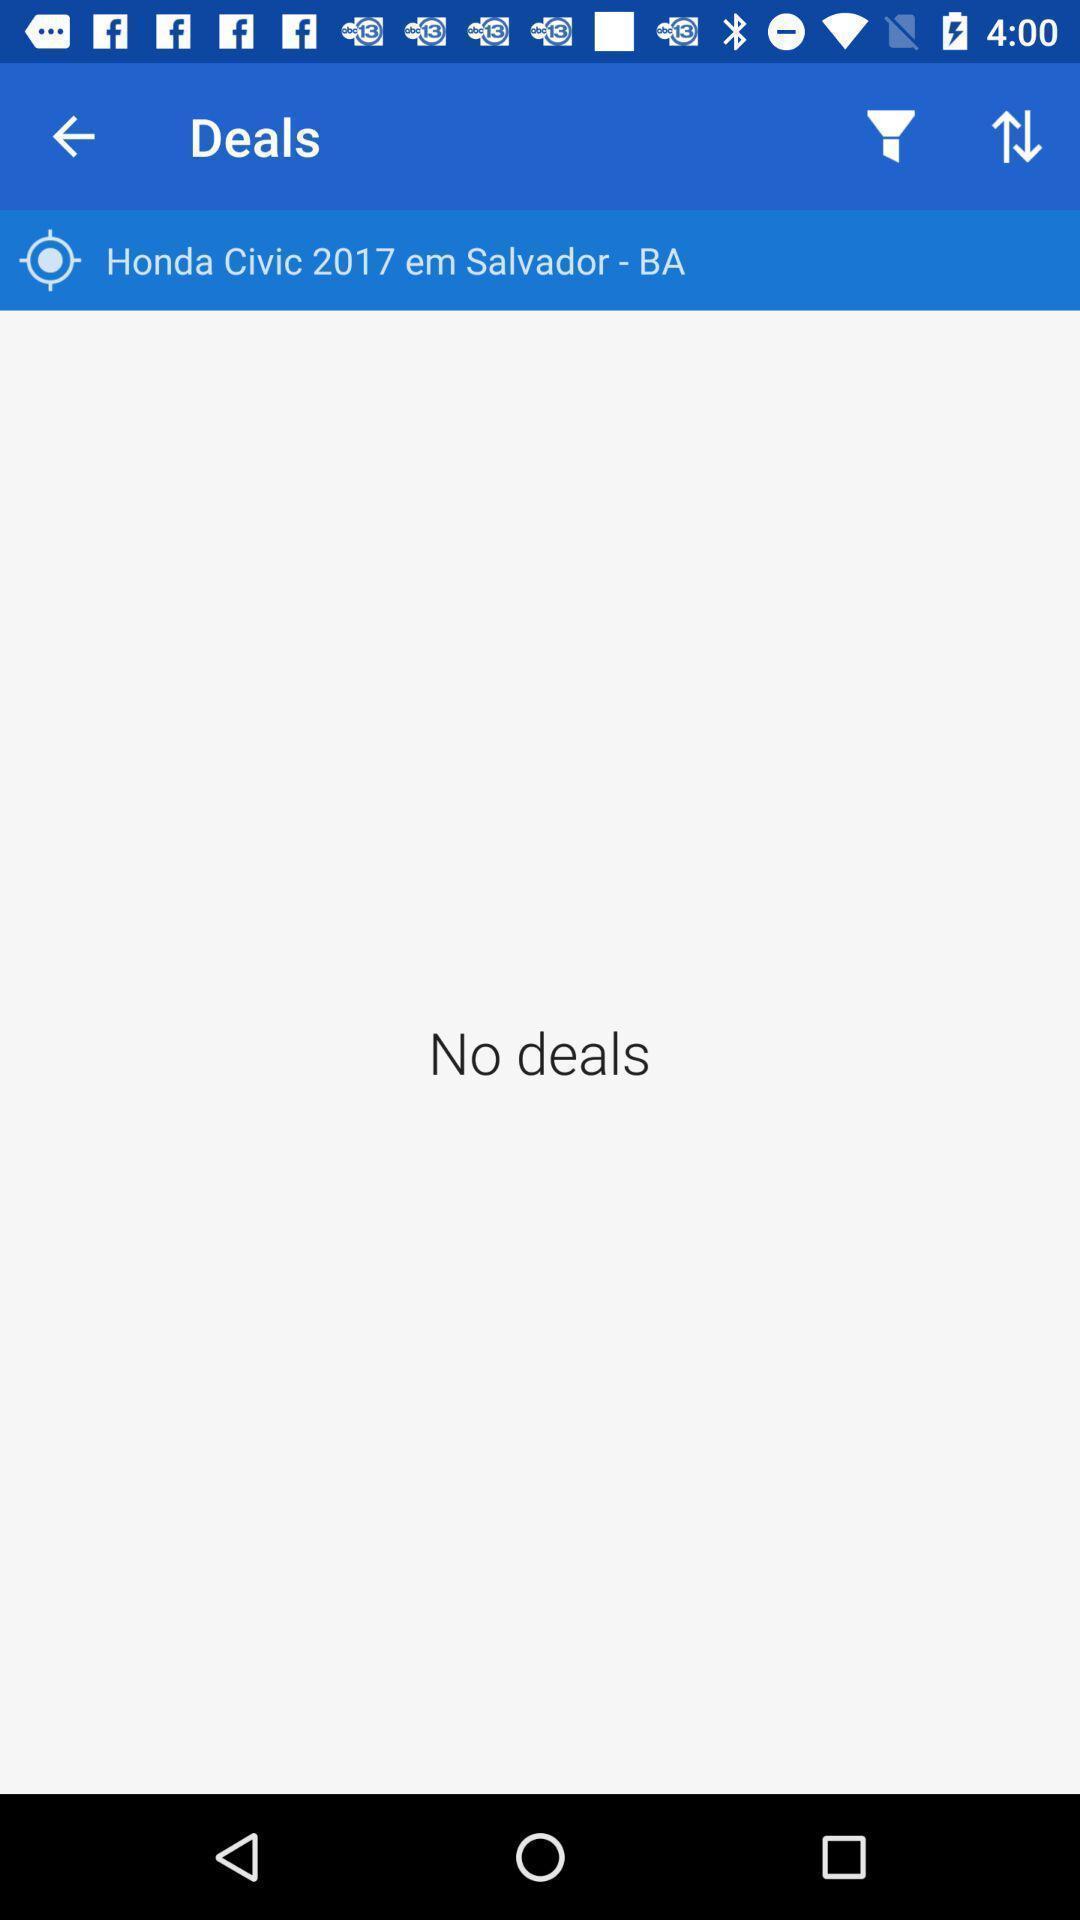Summarize the main components in this picture. Screen displaying the deals page. 